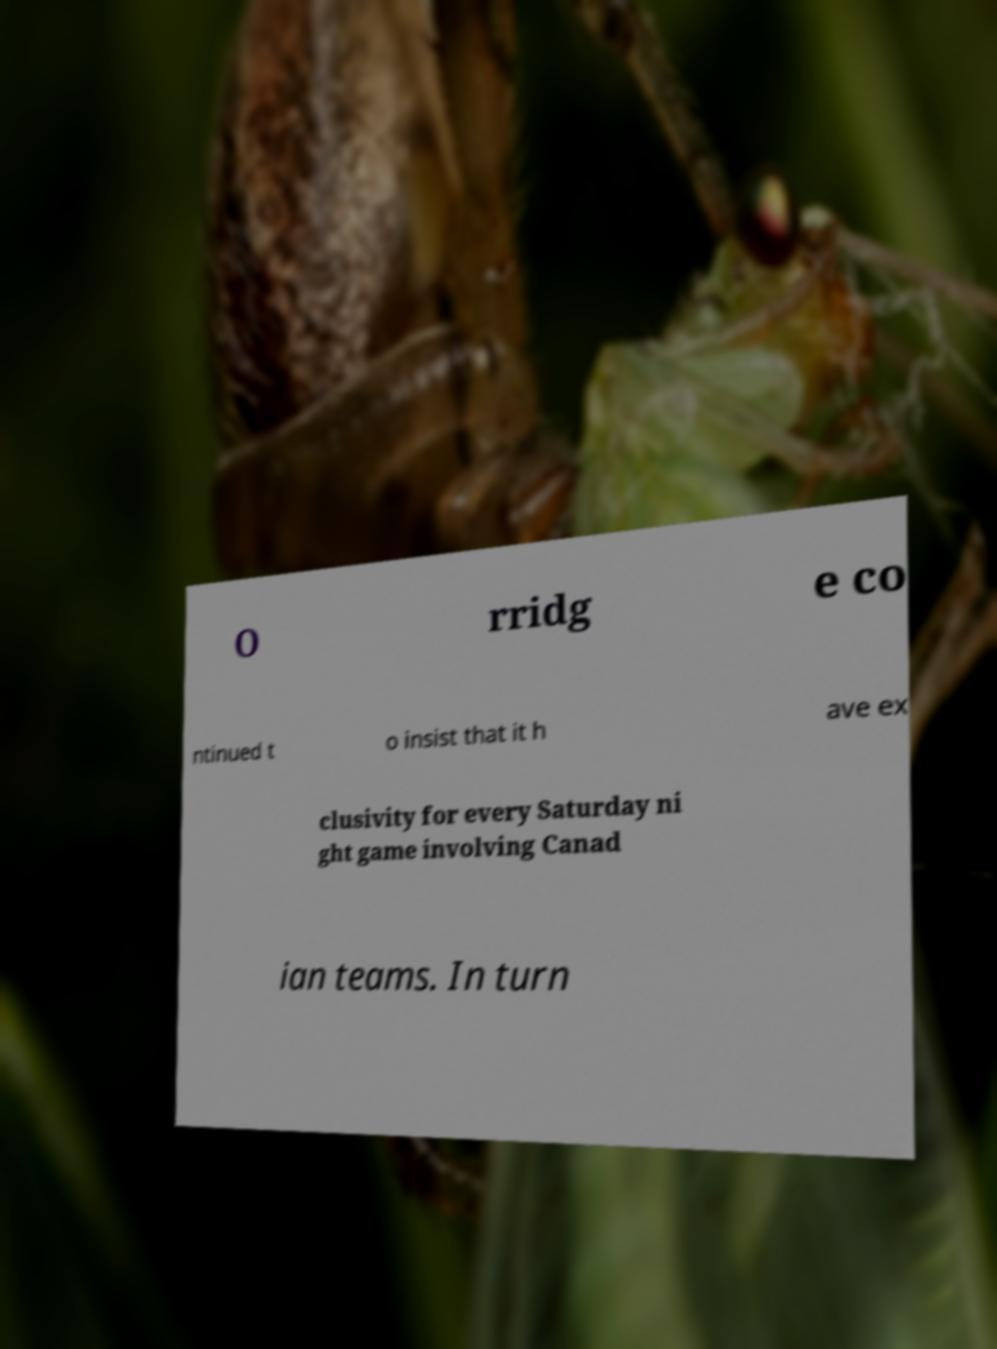Can you accurately transcribe the text from the provided image for me? O rridg e co ntinued t o insist that it h ave ex clusivity for every Saturday ni ght game involving Canad ian teams. In turn 